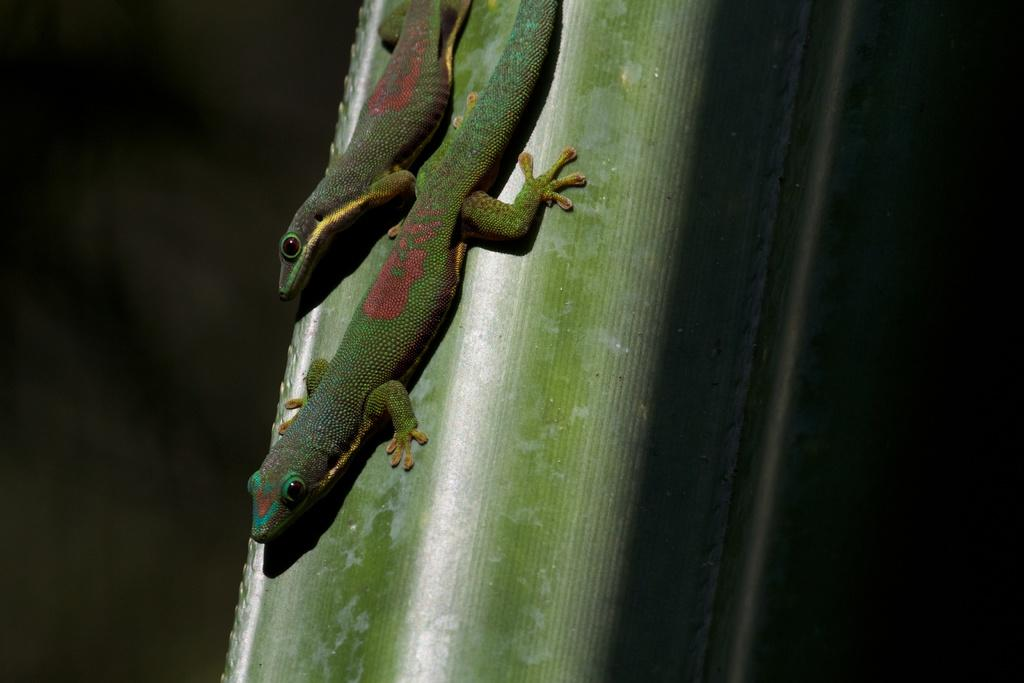What type of animal is in the image? There is a reptile in the image. Where is the reptile located? The reptile is on the branch of a tree. What type of crayon is the spy using to communicate with the government in the image? There is no spy, crayon, or government present in the image; it only features a reptile on a tree branch. 